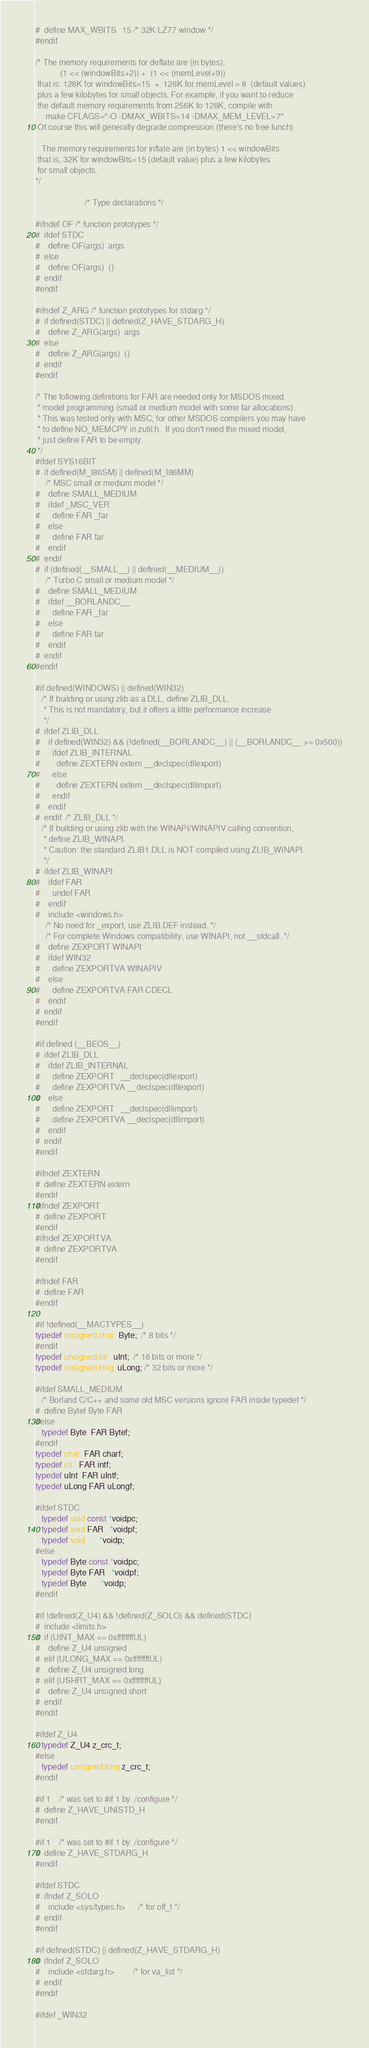<code> <loc_0><loc_0><loc_500><loc_500><_C_>#  define MAX_WBITS   15 /* 32K LZ77 window */
#endif

/* The memory requirements for deflate are (in bytes):
            (1 << (windowBits+2)) +  (1 << (memLevel+9))
 that is: 128K for windowBits=15  +  128K for memLevel = 8  (default values)
 plus a few kilobytes for small objects. For example, if you want to reduce
 the default memory requirements from 256K to 128K, compile with
     make CFLAGS="-O -DMAX_WBITS=14 -DMAX_MEM_LEVEL=7"
 Of course this will generally degrade compression (there's no free lunch).

   The memory requirements for inflate are (in bytes) 1 << windowBits
 that is, 32K for windowBits=15 (default value) plus a few kilobytes
 for small objects.
*/

                        /* Type declarations */

#ifndef OF /* function prototypes */
#  ifdef STDC
#    define OF(args)  args
#  else
#    define OF(args)  ()
#  endif
#endif

#ifndef Z_ARG /* function prototypes for stdarg */
#  if defined(STDC) || defined(Z_HAVE_STDARG_H)
#    define Z_ARG(args)  args
#  else
#    define Z_ARG(args)  ()
#  endif
#endif

/* The following definitions for FAR are needed only for MSDOS mixed
 * model programming (small or medium model with some far allocations).
 * This was tested only with MSC; for other MSDOS compilers you may have
 * to define NO_MEMCPY in zutil.h.  If you don't need the mixed model,
 * just define FAR to be empty.
 */
#ifdef SYS16BIT
#  if defined(M_I86SM) || defined(M_I86MM)
     /* MSC small or medium model */
#    define SMALL_MEDIUM
#    ifdef _MSC_VER
#      define FAR _far
#    else
#      define FAR far
#    endif
#  endif
#  if (defined(__SMALL__) || defined(__MEDIUM__))
     /* Turbo C small or medium model */
#    define SMALL_MEDIUM
#    ifdef __BORLANDC__
#      define FAR _far
#    else
#      define FAR far
#    endif
#  endif
#endif

#if defined(WINDOWS) || defined(WIN32)
   /* If building or using zlib as a DLL, define ZLIB_DLL.
    * This is not mandatory, but it offers a little performance increase.
    */
#  ifdef ZLIB_DLL
#    if defined(WIN32) && (!defined(__BORLANDC__) || (__BORLANDC__ >= 0x500))
#      ifdef ZLIB_INTERNAL
#        define ZEXTERN extern __declspec(dllexport)
#      else
#        define ZEXTERN extern __declspec(dllimport)
#      endif
#    endif
#  endif  /* ZLIB_DLL */
   /* If building or using zlib with the WINAPI/WINAPIV calling convention,
    * define ZLIB_WINAPI.
    * Caution: the standard ZLIB1.DLL is NOT compiled using ZLIB_WINAPI.
    */
#  ifdef ZLIB_WINAPI
#    ifdef FAR
#      undef FAR
#    endif
#    include <windows.h>
     /* No need for _export, use ZLIB.DEF instead. */
     /* For complete Windows compatibility, use WINAPI, not __stdcall. */
#    define ZEXPORT WINAPI
#    ifdef WIN32
#      define ZEXPORTVA WINAPIV
#    else
#      define ZEXPORTVA FAR CDECL
#    endif
#  endif
#endif

#if defined (__BEOS__)
#  ifdef ZLIB_DLL
#    ifdef ZLIB_INTERNAL
#      define ZEXPORT   __declspec(dllexport)
#      define ZEXPORTVA __declspec(dllexport)
#    else
#      define ZEXPORT   __declspec(dllimport)
#      define ZEXPORTVA __declspec(dllimport)
#    endif
#  endif
#endif

#ifndef ZEXTERN
#  define ZEXTERN extern
#endif
#ifndef ZEXPORT
#  define ZEXPORT
#endif
#ifndef ZEXPORTVA
#  define ZEXPORTVA
#endif

#ifndef FAR
#  define FAR
#endif

#if !defined(__MACTYPES__)
typedef unsigned char  Byte;  /* 8 bits */
#endif
typedef unsigned int   uInt;  /* 16 bits or more */
typedef unsigned long  uLong; /* 32 bits or more */

#ifdef SMALL_MEDIUM
   /* Borland C/C++ and some old MSC versions ignore FAR inside typedef */
#  define Bytef Byte FAR
#else
   typedef Byte  FAR Bytef;
#endif
typedef char  FAR charf;
typedef int   FAR intf;
typedef uInt  FAR uIntf;
typedef uLong FAR uLongf;

#ifdef STDC
   typedef void const *voidpc;
   typedef void FAR   *voidpf;
   typedef void       *voidp;
#else
   typedef Byte const *voidpc;
   typedef Byte FAR   *voidpf;
   typedef Byte       *voidp;
#endif

#if !defined(Z_U4) && !defined(Z_SOLO) && defined(STDC)
#  include <limits.h>
#  if (UINT_MAX == 0xffffffffUL)
#    define Z_U4 unsigned
#  elif (ULONG_MAX == 0xffffffffUL)
#    define Z_U4 unsigned long
#  elif (USHRT_MAX == 0xffffffffUL)
#    define Z_U4 unsigned short
#  endif
#endif

#ifdef Z_U4
   typedef Z_U4 z_crc_t;
#else
   typedef unsigned long z_crc_t;
#endif

#if 1    /* was set to #if 1 by ./configure */
#  define Z_HAVE_UNISTD_H
#endif

#if 1    /* was set to #if 1 by ./configure */
#  define Z_HAVE_STDARG_H
#endif

#ifdef STDC
#  ifndef Z_SOLO
#    include <sys/types.h>      /* for off_t */
#  endif
#endif

#if defined(STDC) || defined(Z_HAVE_STDARG_H)
#  ifndef Z_SOLO
#    include <stdarg.h>         /* for va_list */
#  endif
#endif

#ifdef _WIN32</code> 